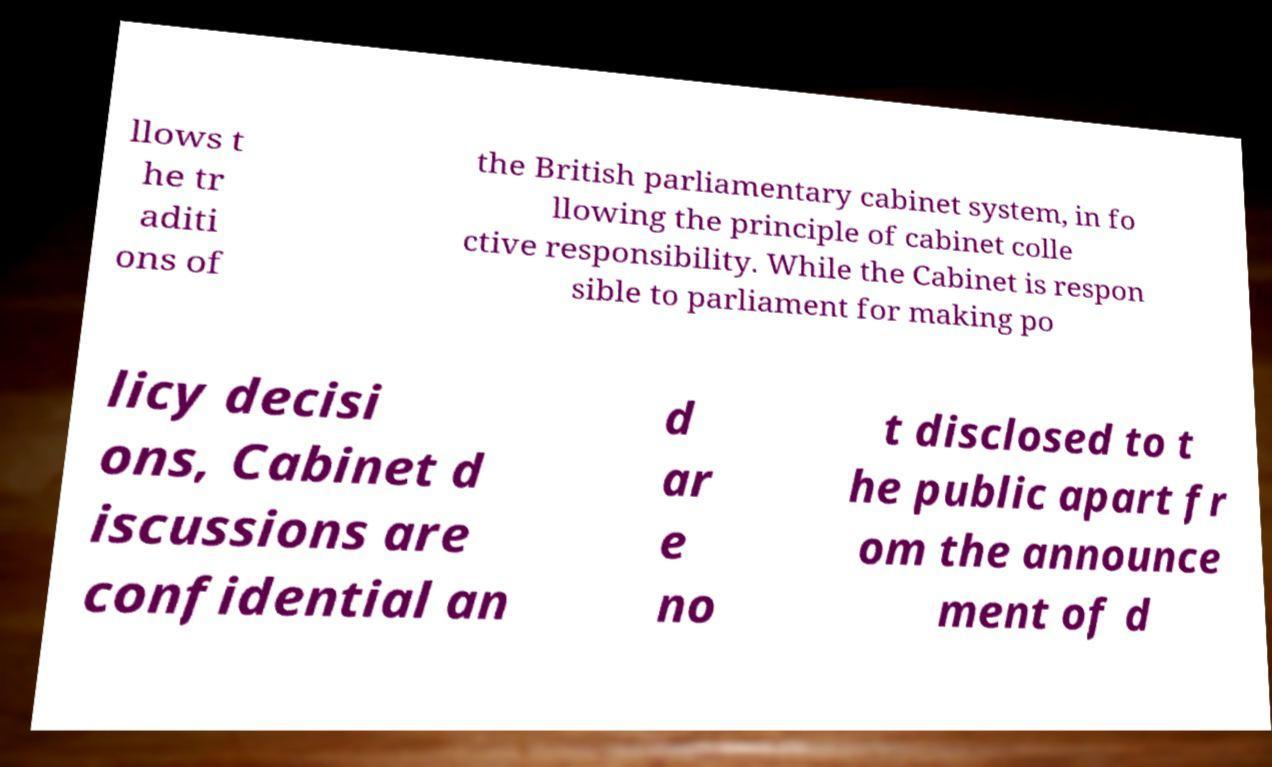For documentation purposes, I need the text within this image transcribed. Could you provide that? llows t he tr aditi ons of the British parliamentary cabinet system, in fo llowing the principle of cabinet colle ctive responsibility. While the Cabinet is respon sible to parliament for making po licy decisi ons, Cabinet d iscussions are confidential an d ar e no t disclosed to t he public apart fr om the announce ment of d 